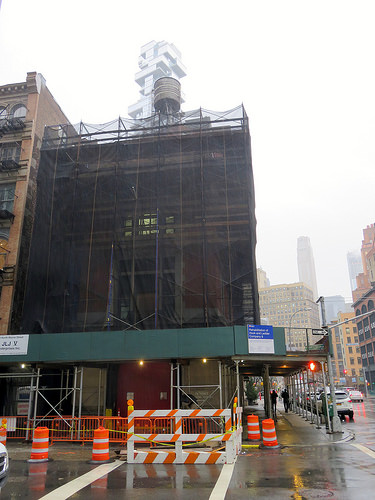<image>
Is there a sky behind the building? Yes. From this viewpoint, the sky is positioned behind the building, with the building partially or fully occluding the sky. 